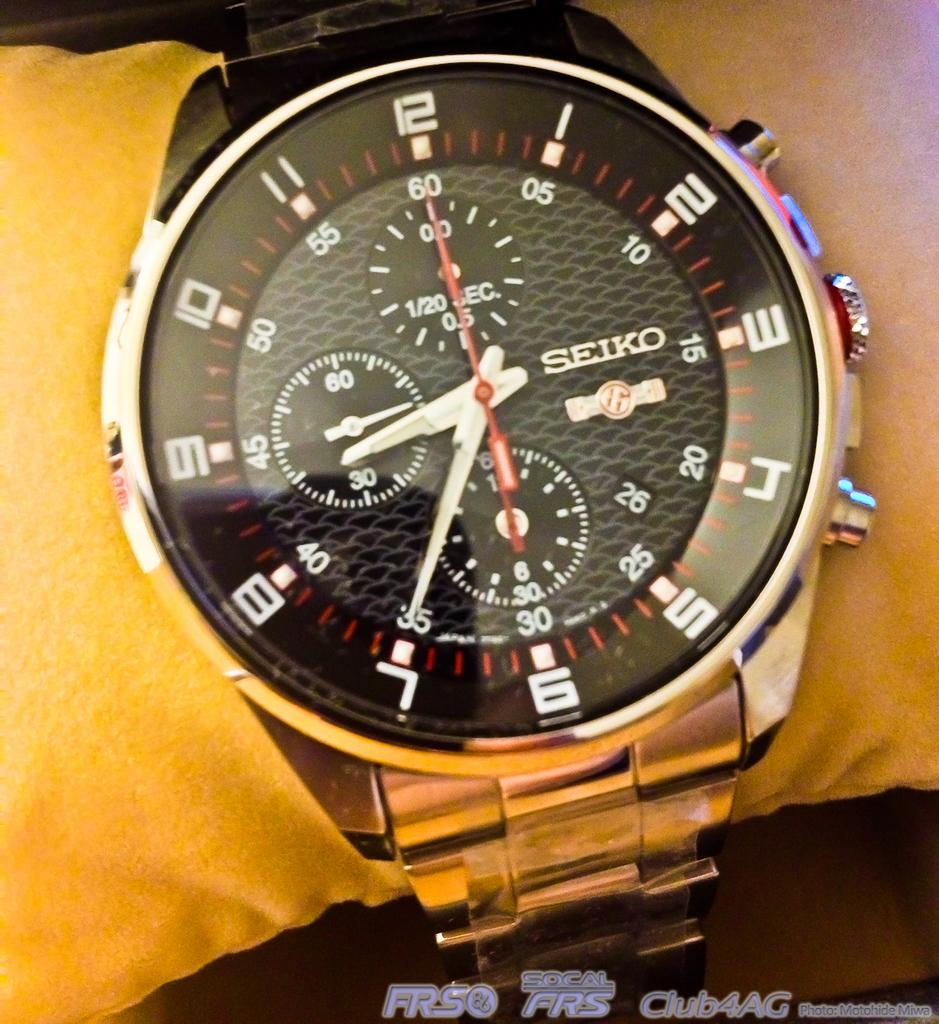<image>
Present a compact description of the photo's key features. a red black and white seiko watch on someone's wrist 